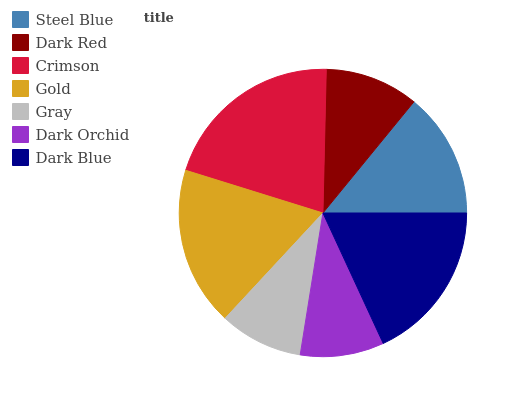Is Gray the minimum?
Answer yes or no. Yes. Is Crimson the maximum?
Answer yes or no. Yes. Is Dark Red the minimum?
Answer yes or no. No. Is Dark Red the maximum?
Answer yes or no. No. Is Steel Blue greater than Dark Red?
Answer yes or no. Yes. Is Dark Red less than Steel Blue?
Answer yes or no. Yes. Is Dark Red greater than Steel Blue?
Answer yes or no. No. Is Steel Blue less than Dark Red?
Answer yes or no. No. Is Steel Blue the high median?
Answer yes or no. Yes. Is Steel Blue the low median?
Answer yes or no. Yes. Is Gray the high median?
Answer yes or no. No. Is Gray the low median?
Answer yes or no. No. 